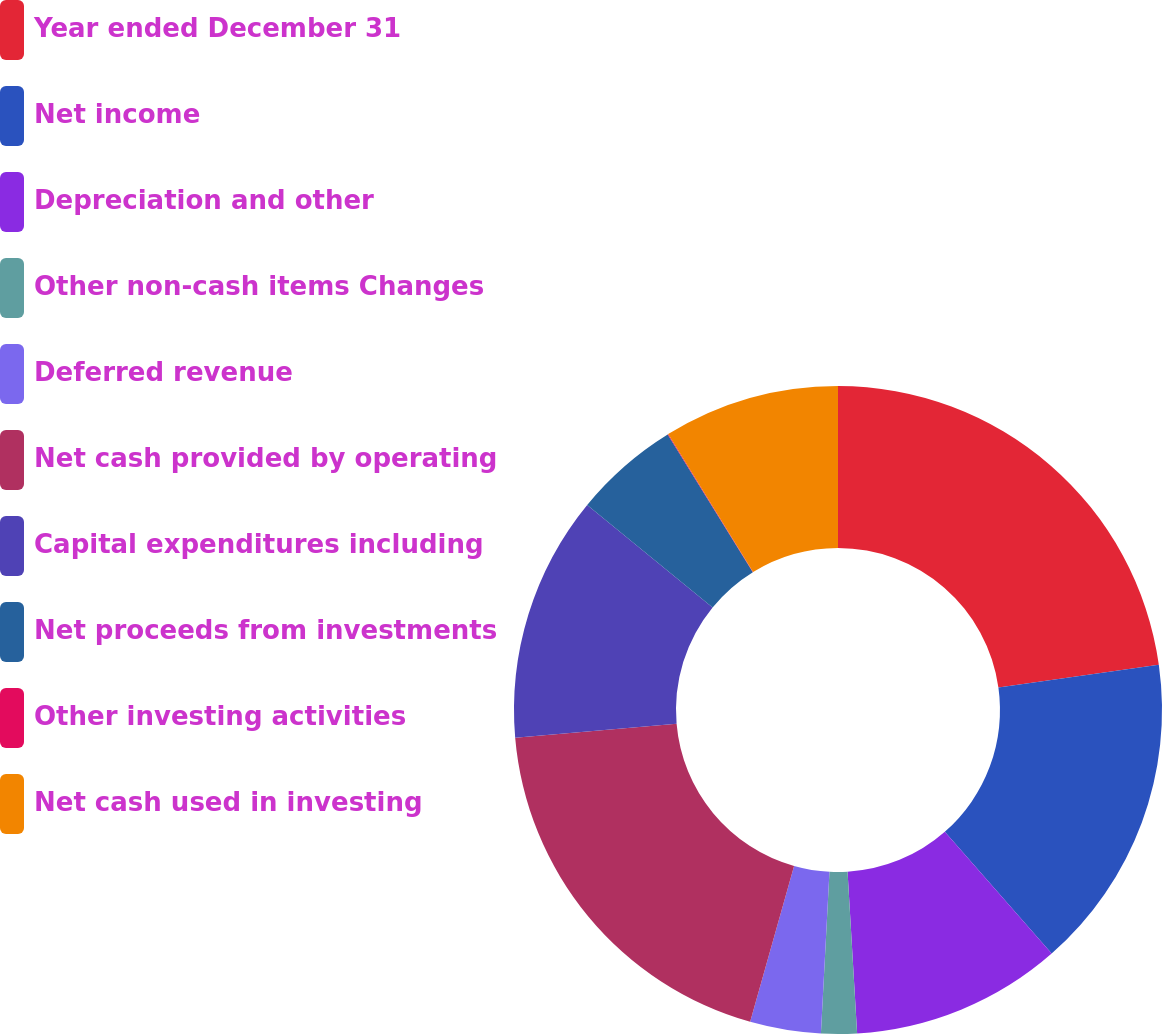<chart> <loc_0><loc_0><loc_500><loc_500><pie_chart><fcel>Year ended December 31<fcel>Net income<fcel>Depreciation and other<fcel>Other non-cash items Changes<fcel>Deferred revenue<fcel>Net cash provided by operating<fcel>Capital expenditures including<fcel>Net proceeds from investments<fcel>Other investing activities<fcel>Net cash used in investing<nl><fcel>22.77%<fcel>15.77%<fcel>10.52%<fcel>1.78%<fcel>3.53%<fcel>19.27%<fcel>12.27%<fcel>5.28%<fcel>0.03%<fcel>8.78%<nl></chart> 